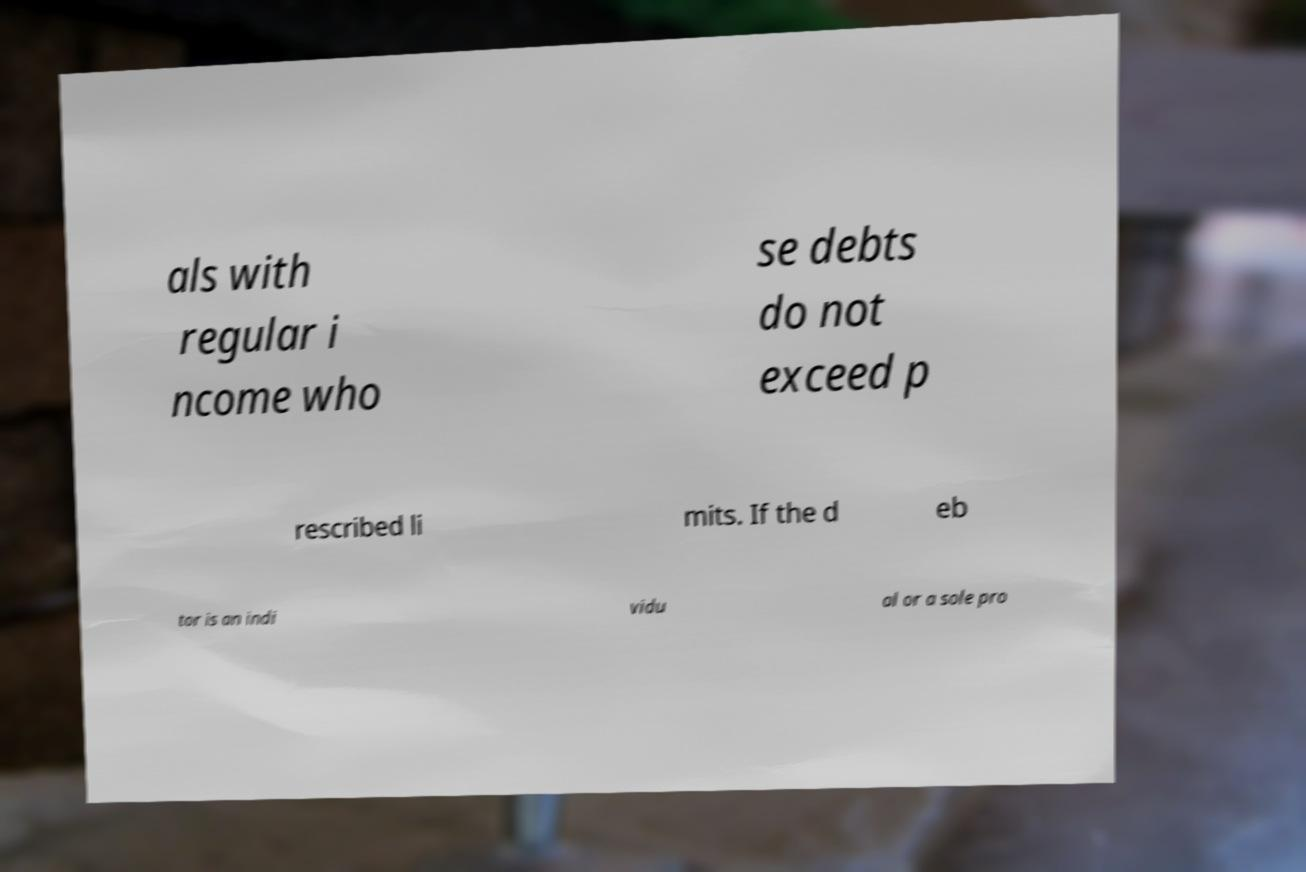There's text embedded in this image that I need extracted. Can you transcribe it verbatim? als with regular i ncome who se debts do not exceed p rescribed li mits. If the d eb tor is an indi vidu al or a sole pro 